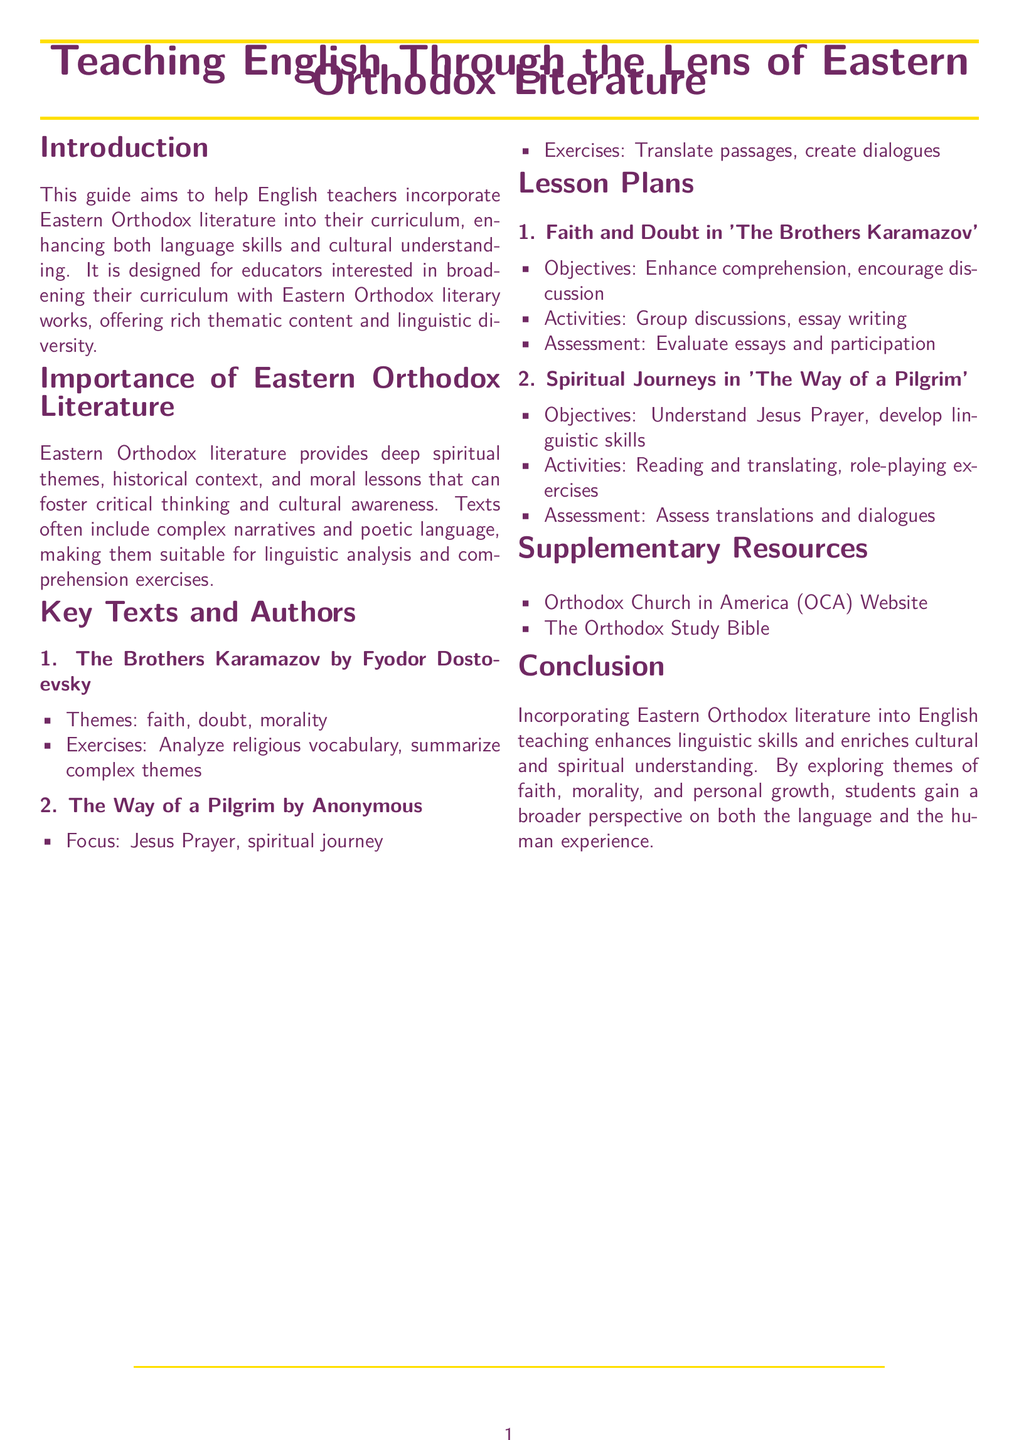What is the main purpose of the guide? The guide aims to help English teachers incorporate Eastern Orthodox literature into their curriculum.
Answer: To help teachers incorporate Eastern Orthodox literature What is one of the key texts discussed in the guide? The guide lists 'The Brothers Karamazov' as one of the key texts.
Answer: The Brothers Karamazov What theme is associated with 'The Brothers Karamazov'? The guide includes faith as a theme associated with 'The Brothers Karamazov'.
Answer: Faith What type of exercise is suggested for 'The Way of a Pilgrim'? The guide suggests translation of passages as an exercise for 'The Way of a Pilgrim'.
Answer: Translate passages What is one objective of the lesson plan on 'The Brothers Karamazov'? The lesson plan aims to enhance comprehension for 'The Brothers Karamazov'.
Answer: Enhance comprehension What is the focus of 'The Way of a Pilgrim'? The guide states that the focus is on the Jesus Prayer and spiritual journey.
Answer: Jesus Prayer What type of resource is mentioned as a supplementary resource? The Orthodox Study Bible is mentioned as a supplementary resource.
Answer: The Orthodox Study Bible How many lesson plans are mentioned in the document? The document mentions two lesson plans.
Answer: Two What is a key benefit of incorporating Eastern Orthodox literature into English teaching? The guide states it enriches cultural and spiritual understanding.
Answer: Enriches cultural and spiritual understanding 